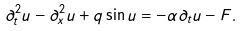Convert formula to latex. <formula><loc_0><loc_0><loc_500><loc_500>\partial ^ { 2 } _ { t } u - \partial ^ { 2 } _ { x } u + q \sin u = - \alpha \partial _ { t } u - F .</formula> 